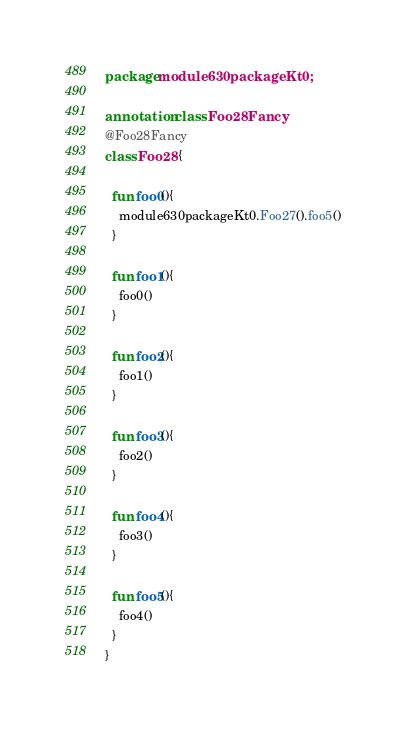Convert code to text. <code><loc_0><loc_0><loc_500><loc_500><_Kotlin_>package module630packageKt0;

annotation class Foo28Fancy
@Foo28Fancy
class Foo28 {

  fun foo0(){
    module630packageKt0.Foo27().foo5()
  }

  fun foo1(){
    foo0()
  }

  fun foo2(){
    foo1()
  }

  fun foo3(){
    foo2()
  }

  fun foo4(){
    foo3()
  }

  fun foo5(){
    foo4()
  }
}</code> 